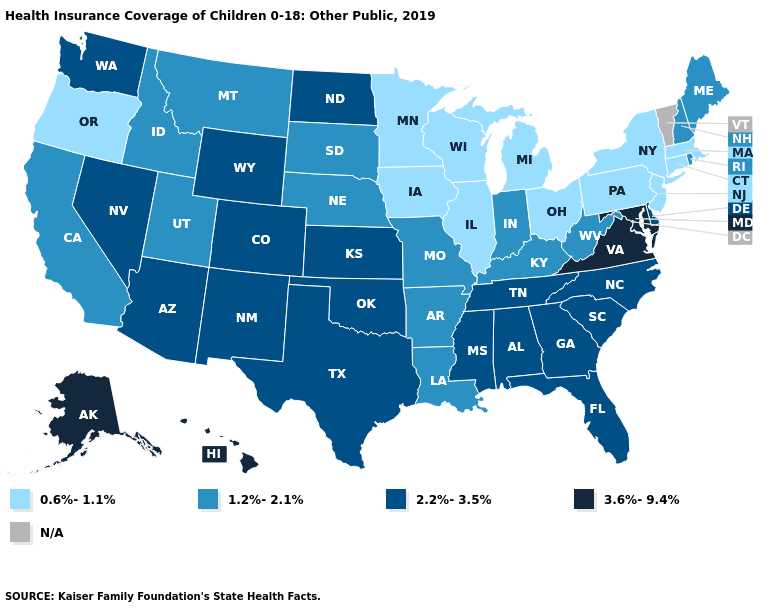Among the states that border Virginia , does Tennessee have the lowest value?
Be succinct. No. Name the states that have a value in the range 2.2%-3.5%?
Write a very short answer. Alabama, Arizona, Colorado, Delaware, Florida, Georgia, Kansas, Mississippi, Nevada, New Mexico, North Carolina, North Dakota, Oklahoma, South Carolina, Tennessee, Texas, Washington, Wyoming. What is the highest value in states that border Louisiana?
Write a very short answer. 2.2%-3.5%. What is the value of New Hampshire?
Quick response, please. 1.2%-2.1%. Is the legend a continuous bar?
Concise answer only. No. Name the states that have a value in the range 0.6%-1.1%?
Give a very brief answer. Connecticut, Illinois, Iowa, Massachusetts, Michigan, Minnesota, New Jersey, New York, Ohio, Oregon, Pennsylvania, Wisconsin. Which states have the lowest value in the USA?
Quick response, please. Connecticut, Illinois, Iowa, Massachusetts, Michigan, Minnesota, New Jersey, New York, Ohio, Oregon, Pennsylvania, Wisconsin. Which states have the highest value in the USA?
Be succinct. Alaska, Hawaii, Maryland, Virginia. What is the highest value in states that border Connecticut?
Answer briefly. 1.2%-2.1%. Among the states that border Wisconsin , which have the lowest value?
Give a very brief answer. Illinois, Iowa, Michigan, Minnesota. What is the value of North Dakota?
Give a very brief answer. 2.2%-3.5%. What is the value of Kansas?
Keep it brief. 2.2%-3.5%. What is the value of Mississippi?
Quick response, please. 2.2%-3.5%. Does Montana have the lowest value in the USA?
Be succinct. No. 